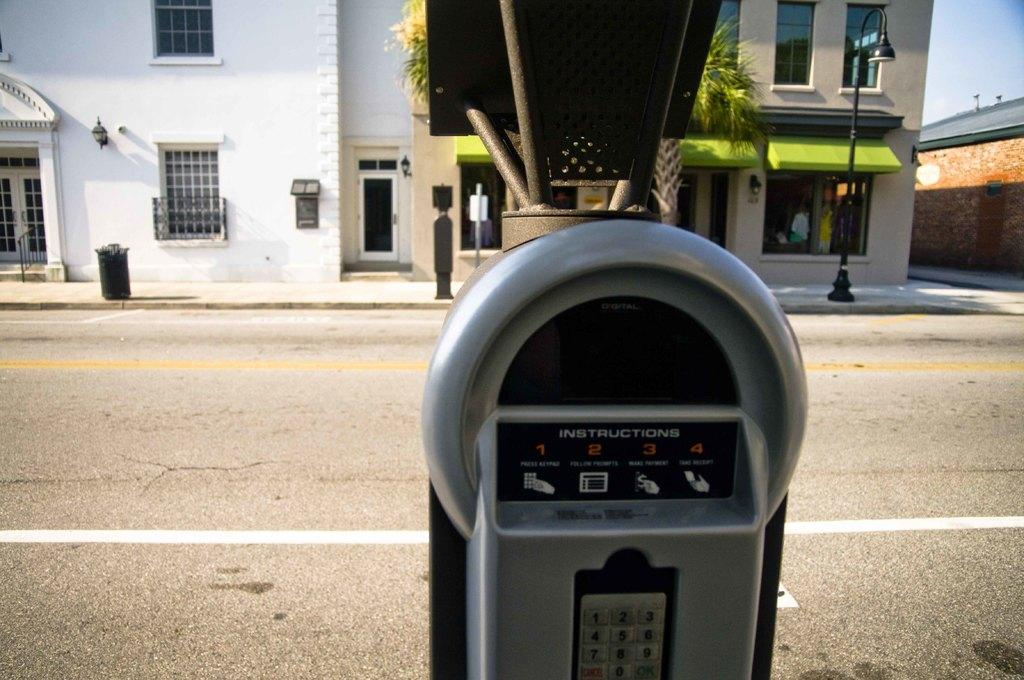<image>
Share a concise interpretation of the image provided. A parking meter which states INSTRUCTIONS that has a panel with numbers 1-9 and 0 on the keypad 